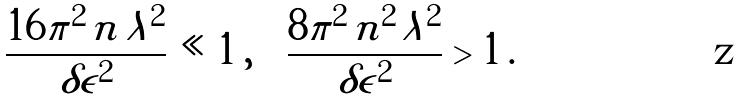Convert formula to latex. <formula><loc_0><loc_0><loc_500><loc_500>\frac { 1 6 \pi ^ { 2 } \, n \, \lambda ^ { 2 } } { \delta \epsilon ^ { 2 } } \ll 1 \, , \quad \frac { 8 \pi ^ { 2 } \, n ^ { 2 } \, \lambda ^ { 2 } } { \delta \epsilon ^ { 2 } } > 1 \, .</formula> 